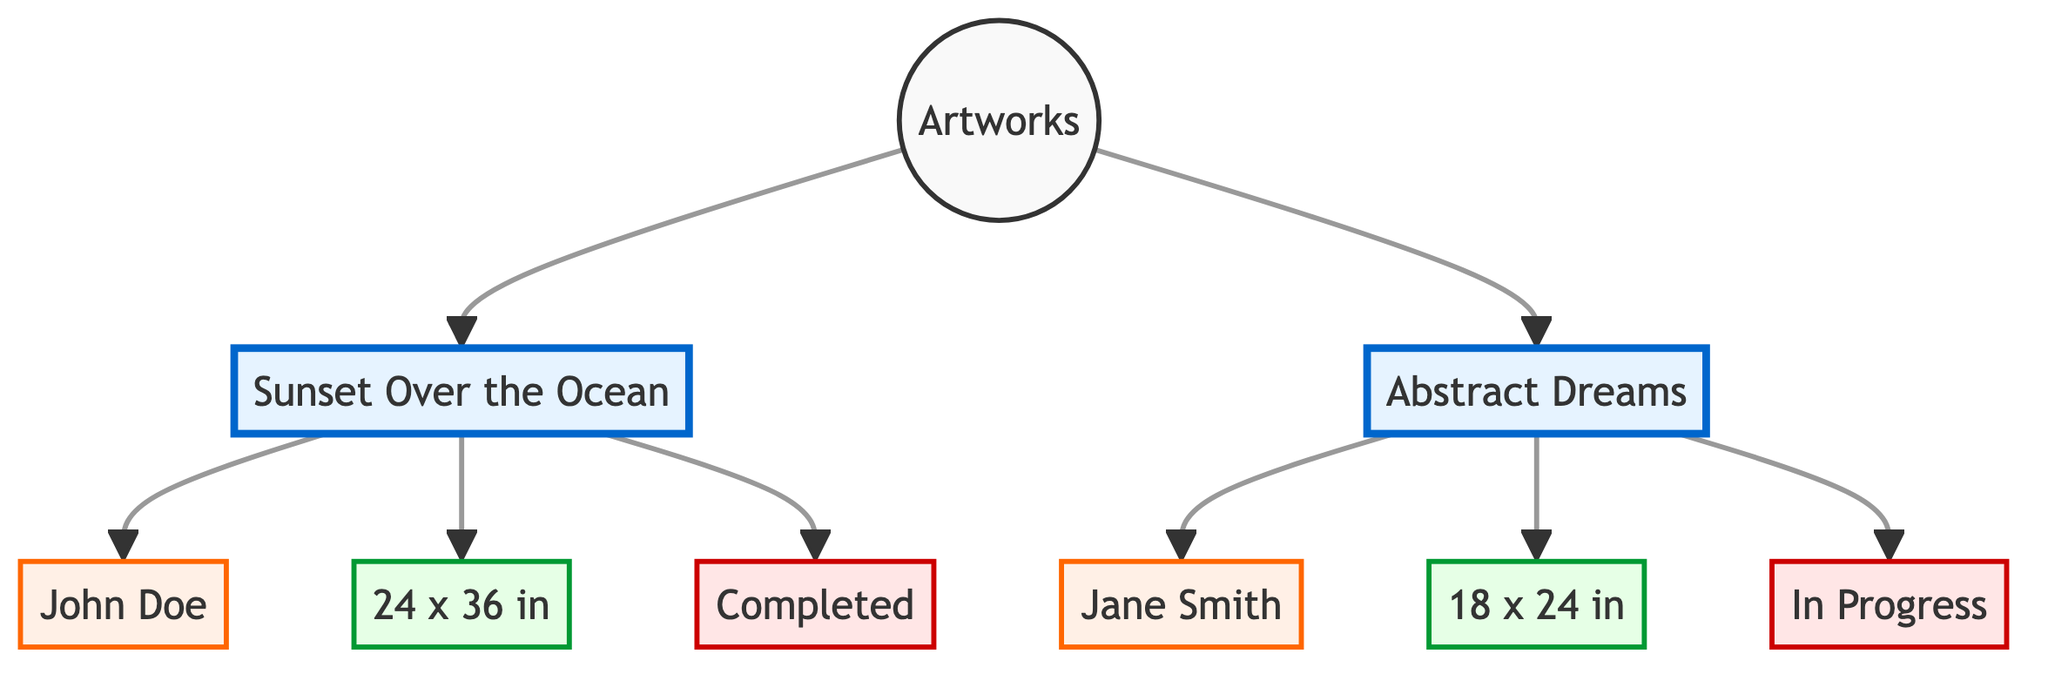What is the label of the first artwork? The first artwork listed in the diagram is connected directly to the "Artworks" node and is labeled as "Sunset Over the Ocean".
Answer: Sunset Over the Ocean Who is the artist of "Abstract Dreams"? The "Abstract Dreams" artwork node points to the "Artist_2" node, which is labeled as "Jane Smith".
Answer: Jane Smith What are the dimensions of "Sunset Over the Ocean"? The dimensions of "Sunset Over the Ocean" can be traced by following the connection from "Artwork_1" to "Dimensions_1", which notes "24 x 36 in".
Answer: 24 x 36 in How many artworks are listed in the inventory? The diagram shows two artworks connected to the "Artworks" node: "Sunset Over the Ocean" and "Abstract Dreams". Therefore, the count is two.
Answer: 2 What is the file status of "Abstract Dreams"? Following the connections from "Artwork_2", we arrive at "FileStatus_2", which indicates "In Progress".
Answer: In Progress Which artwork has a completed file status? The node "FileStatus_1" linked to "Artwork_1" indicates that the file status for "Sunset Over the Ocean" is "Completed".
Answer: Completed How many edges are present in the diagram? Counting all connections between nodes shows there are a total of eight edges that connect the four artworks to their respective artists, dimensions, and file statuses.
Answer: 8 Which artist has created more than one artwork? Based on the structure of the diagram, each artwork is associated with a specific artist, and there are no artists connected to more than one artwork; thus, the answer is none.
Answer: None What is the label of the node connected to "Dimensions_2"? The "Dimensions_2" node is linked to "Artwork_2", which is "Abstract Dreams".
Answer: Abstract Dreams 